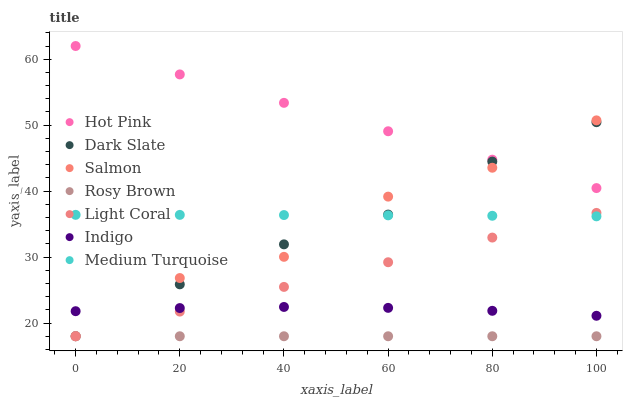Does Rosy Brown have the minimum area under the curve?
Answer yes or no. Yes. Does Hot Pink have the maximum area under the curve?
Answer yes or no. Yes. Does Indigo have the minimum area under the curve?
Answer yes or no. No. Does Indigo have the maximum area under the curve?
Answer yes or no. No. Is Light Coral the smoothest?
Answer yes or no. Yes. Is Salmon the roughest?
Answer yes or no. Yes. Is Indigo the smoothest?
Answer yes or no. No. Is Indigo the roughest?
Answer yes or no. No. Does Rosy Brown have the lowest value?
Answer yes or no. Yes. Does Indigo have the lowest value?
Answer yes or no. No. Does Hot Pink have the highest value?
Answer yes or no. Yes. Does Indigo have the highest value?
Answer yes or no. No. Is Medium Turquoise less than Hot Pink?
Answer yes or no. Yes. Is Hot Pink greater than Light Coral?
Answer yes or no. Yes. Does Rosy Brown intersect Salmon?
Answer yes or no. Yes. Is Rosy Brown less than Salmon?
Answer yes or no. No. Is Rosy Brown greater than Salmon?
Answer yes or no. No. Does Medium Turquoise intersect Hot Pink?
Answer yes or no. No. 